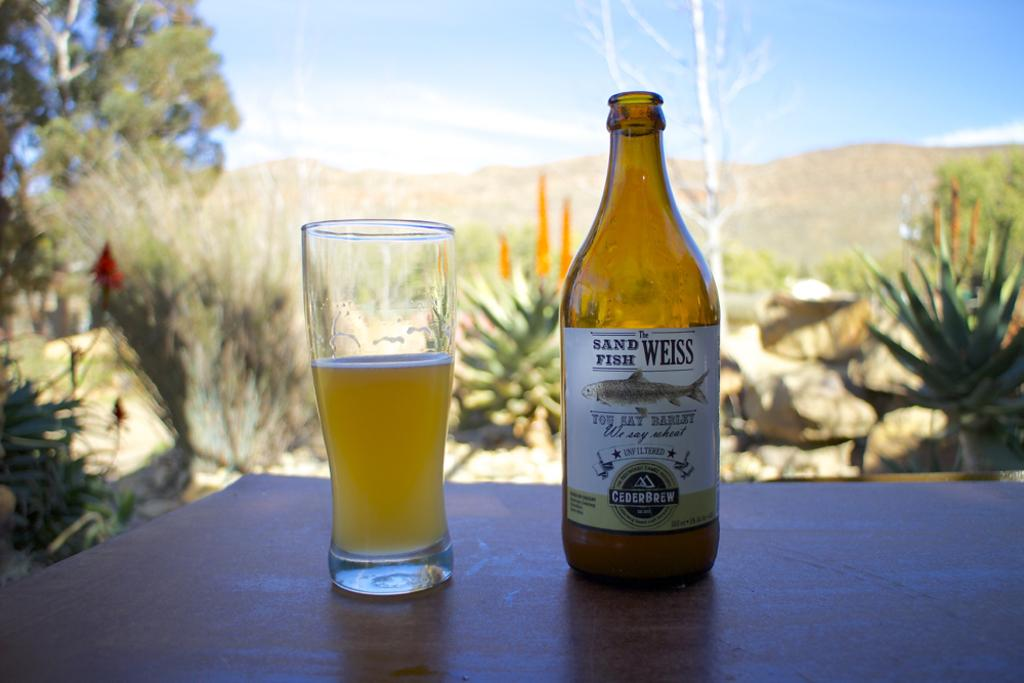<image>
Describe the image concisely. Full glass and bottle of Sand Fish Weiss you say barley we say wheat brand of beer on a table 